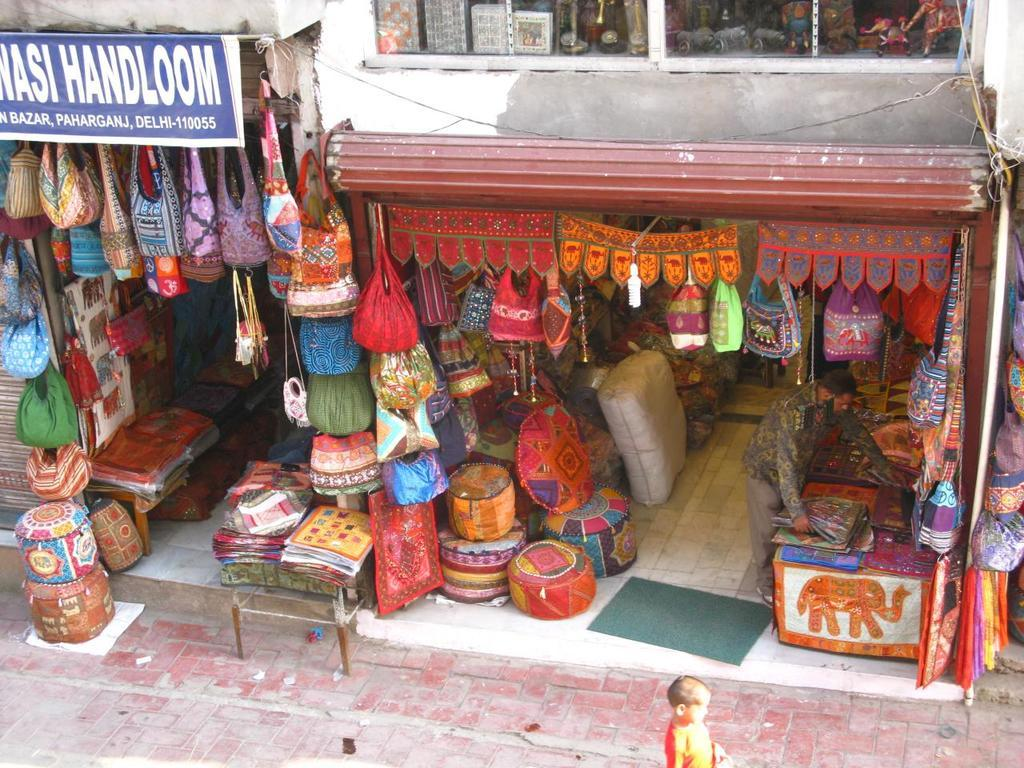Provide a one-sentence caption for the provided image. A shop with Handloom on a sign over one part of it. 